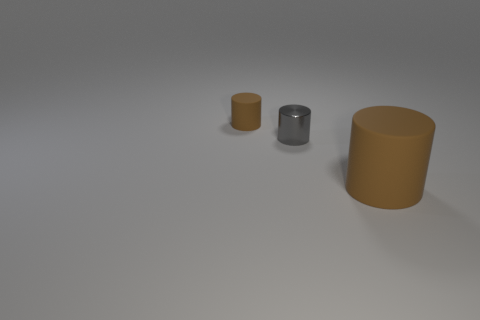Subtract 1 cylinders. How many cylinders are left? 2 Subtract all small cylinders. How many cylinders are left? 1 Add 2 tiny green rubber objects. How many objects exist? 5 Subtract all red cylinders. Subtract all red blocks. How many cylinders are left? 3 Add 3 small rubber things. How many small rubber things are left? 4 Add 3 large brown objects. How many large brown objects exist? 4 Subtract 0 cyan balls. How many objects are left? 3 Subtract all large rubber cylinders. Subtract all gray metallic objects. How many objects are left? 1 